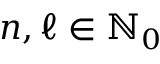Convert formula to latex. <formula><loc_0><loc_0><loc_500><loc_500>n , \ell \in { \mathbb { N } } _ { 0 }</formula> 